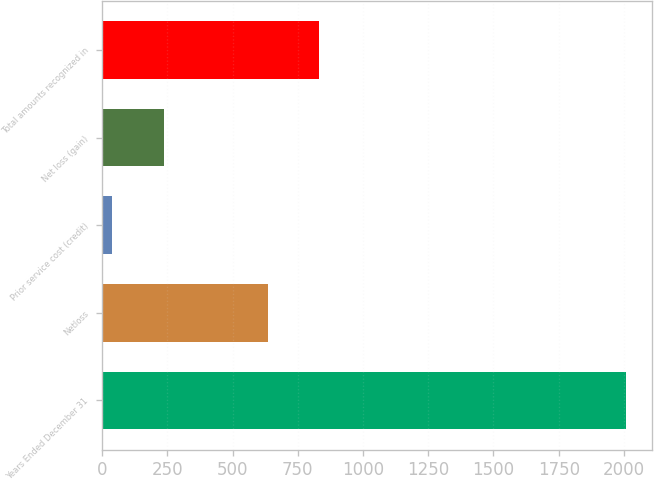Convert chart to OTSL. <chart><loc_0><loc_0><loc_500><loc_500><bar_chart><fcel>Years Ended December 31<fcel>Netloss<fcel>Prior service cost (credit)<fcel>Net loss (gain)<fcel>Total amounts recognized in<nl><fcel>2007<fcel>636<fcel>39<fcel>235.8<fcel>832.8<nl></chart> 